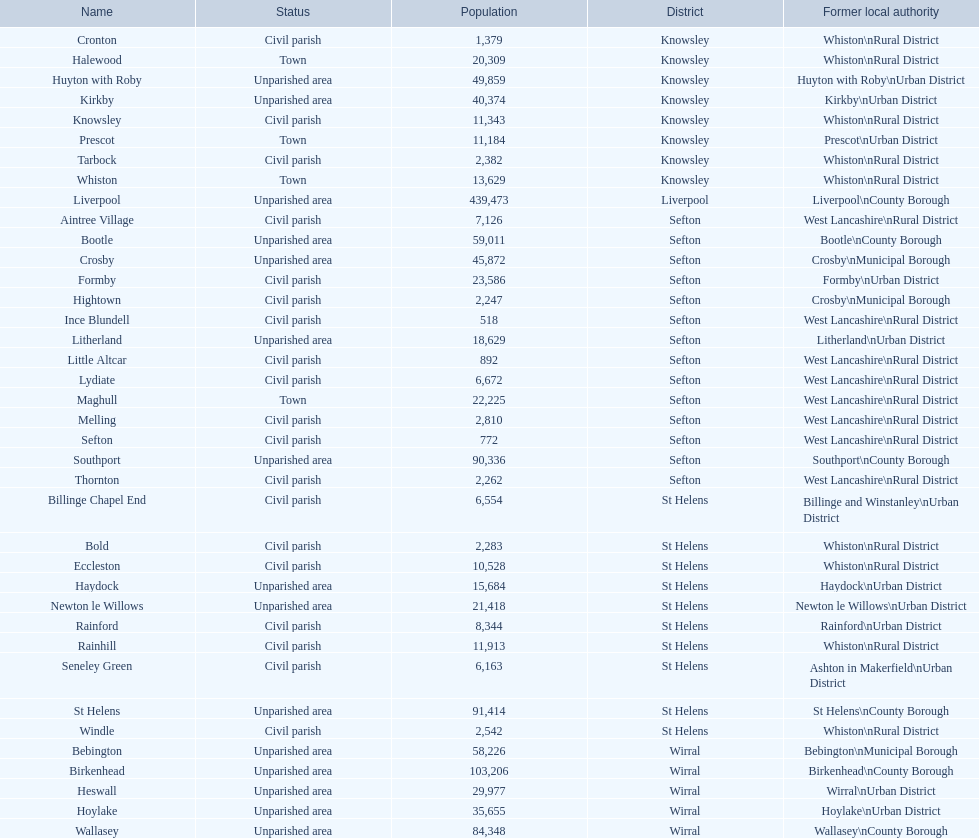How many civil parishes can be found with populations of 10,000 and above? 4. 